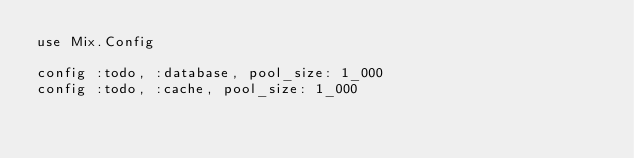Convert code to text. <code><loc_0><loc_0><loc_500><loc_500><_Elixir_>use Mix.Config

config :todo, :database, pool_size: 1_000
config :todo, :cache, pool_size: 1_000
</code> 